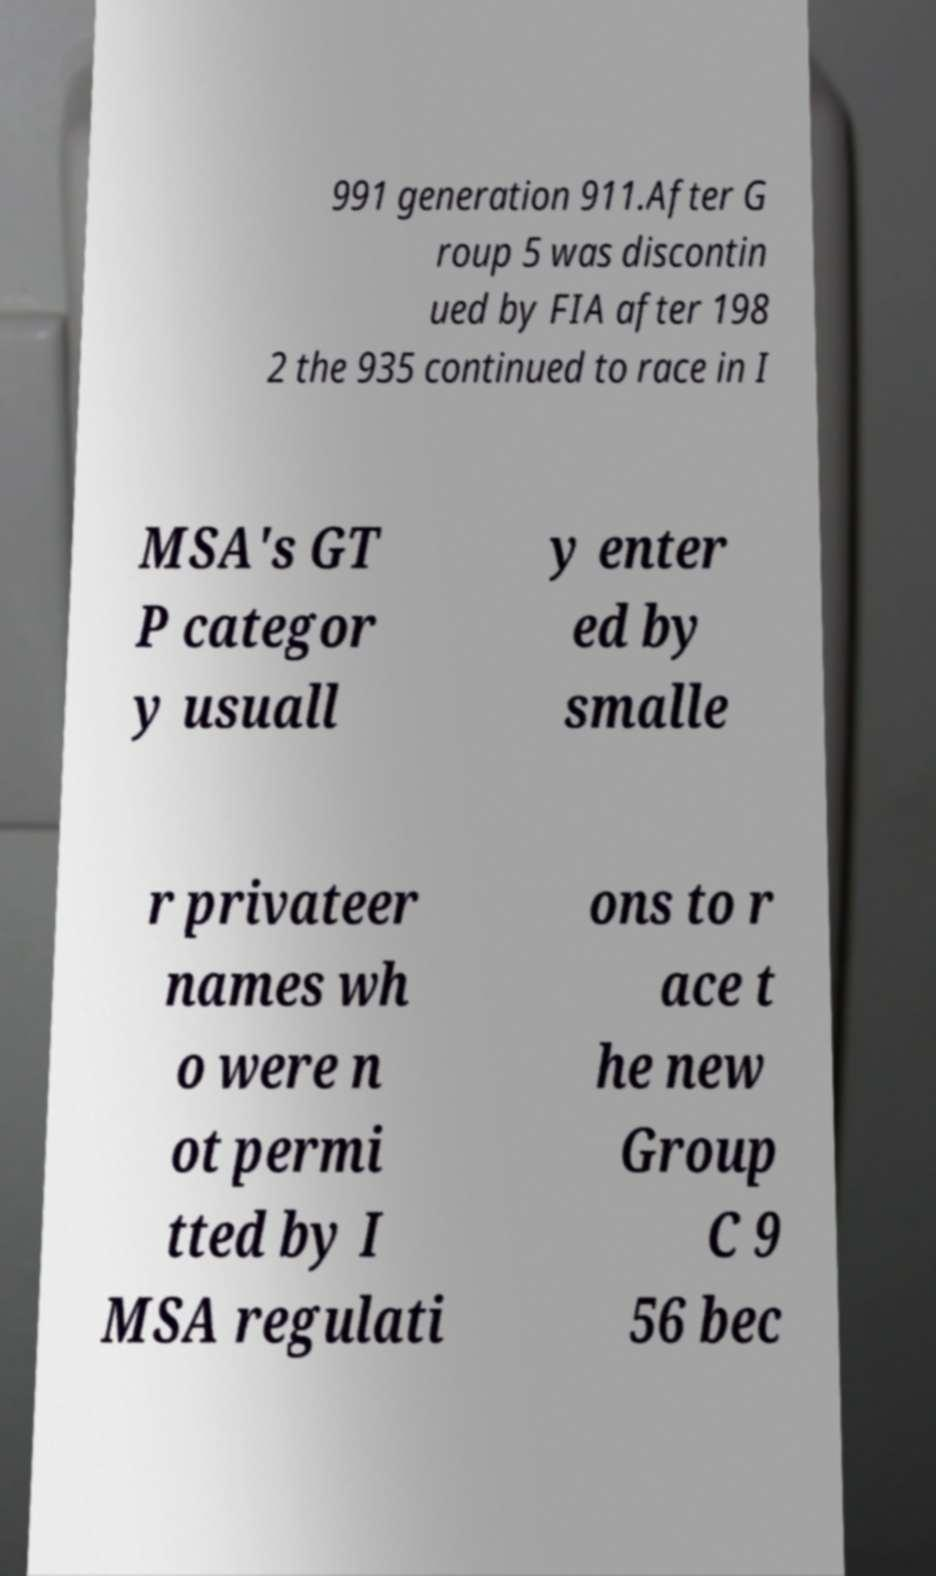What messages or text are displayed in this image? I need them in a readable, typed format. 991 generation 911.After G roup 5 was discontin ued by FIA after 198 2 the 935 continued to race in I MSA's GT P categor y usuall y enter ed by smalle r privateer names wh o were n ot permi tted by I MSA regulati ons to r ace t he new Group C 9 56 bec 